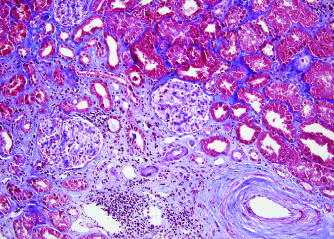does a speckled pattern result from arteriosclerosis of arteries and arterioles in a chronically rejecting kidney allograft?
Answer the question using a single word or phrase. No 